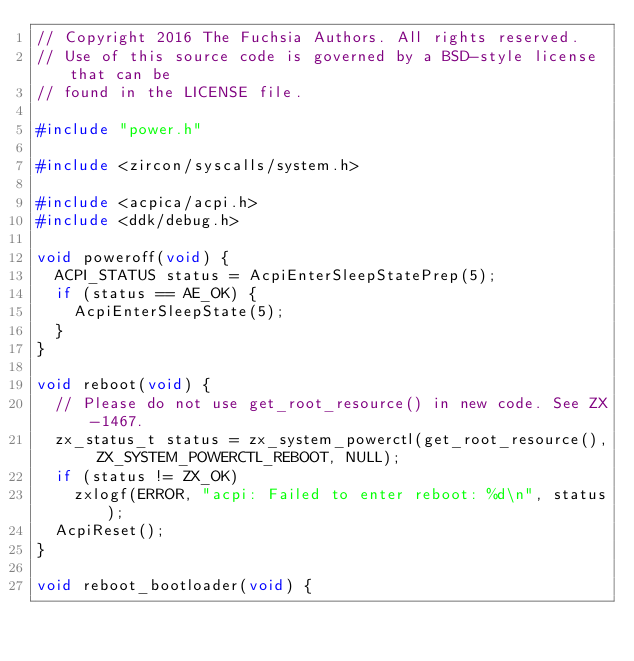Convert code to text. <code><loc_0><loc_0><loc_500><loc_500><_C_>// Copyright 2016 The Fuchsia Authors. All rights reserved.
// Use of this source code is governed by a BSD-style license that can be
// found in the LICENSE file.

#include "power.h"

#include <zircon/syscalls/system.h>

#include <acpica/acpi.h>
#include <ddk/debug.h>

void poweroff(void) {
  ACPI_STATUS status = AcpiEnterSleepStatePrep(5);
  if (status == AE_OK) {
    AcpiEnterSleepState(5);
  }
}

void reboot(void) {
  // Please do not use get_root_resource() in new code. See ZX-1467.
  zx_status_t status = zx_system_powerctl(get_root_resource(), ZX_SYSTEM_POWERCTL_REBOOT, NULL);
  if (status != ZX_OK)
    zxlogf(ERROR, "acpi: Failed to enter reboot: %d\n", status);
  AcpiReset();
}

void reboot_bootloader(void) {</code> 